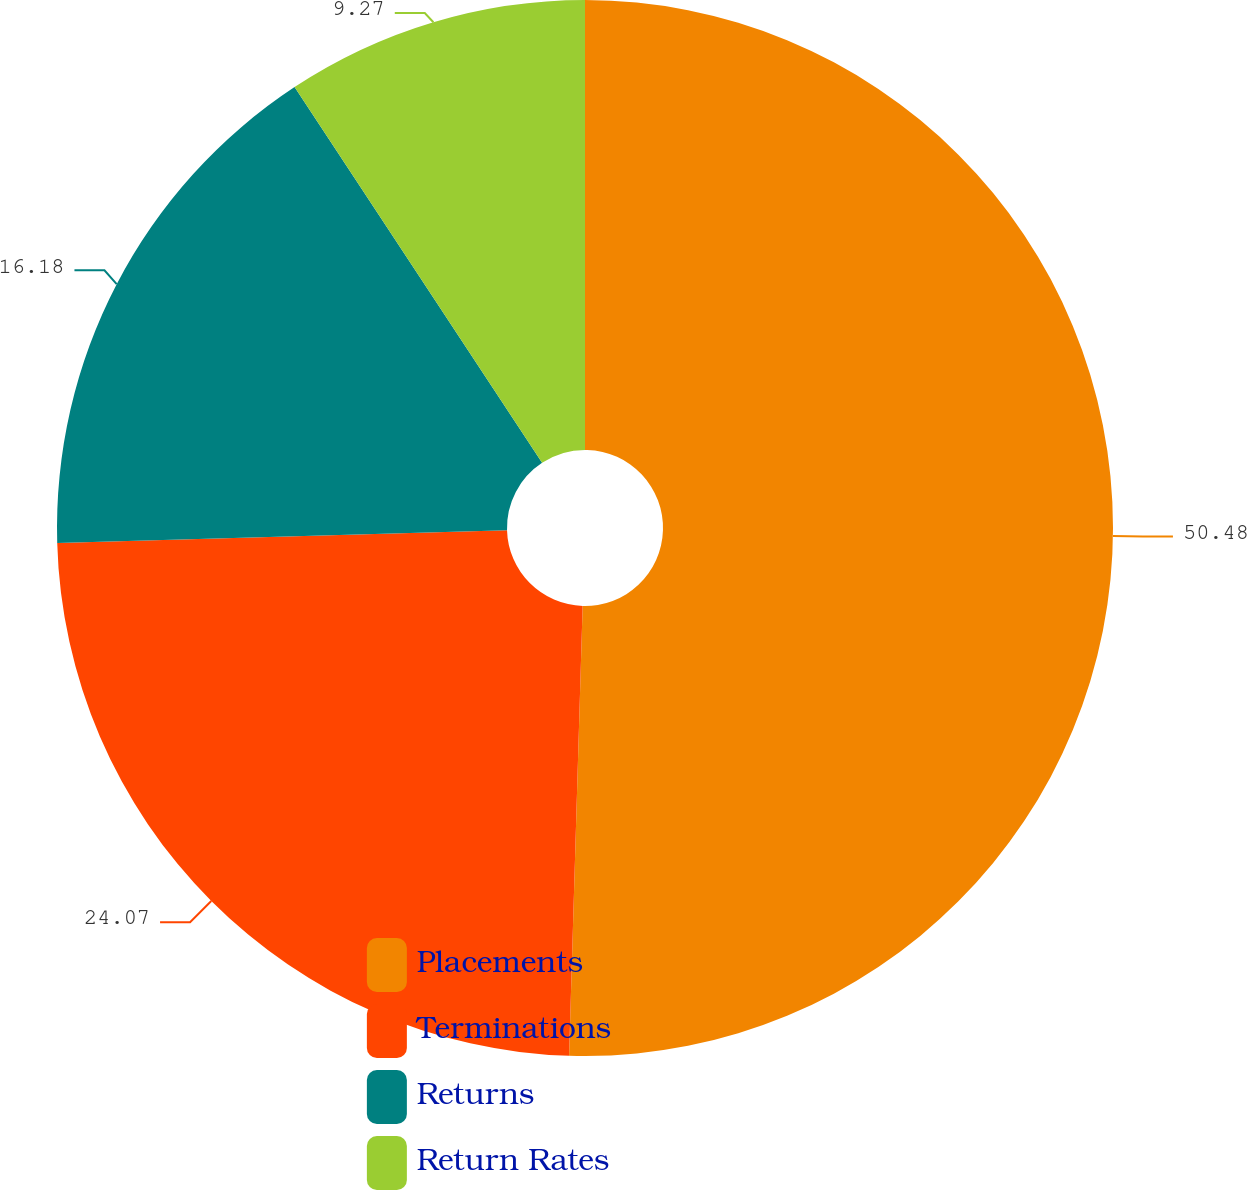Convert chart to OTSL. <chart><loc_0><loc_0><loc_500><loc_500><pie_chart><fcel>Placements<fcel>Terminations<fcel>Returns<fcel>Return Rates<nl><fcel>50.48%<fcel>24.07%<fcel>16.18%<fcel>9.27%<nl></chart> 